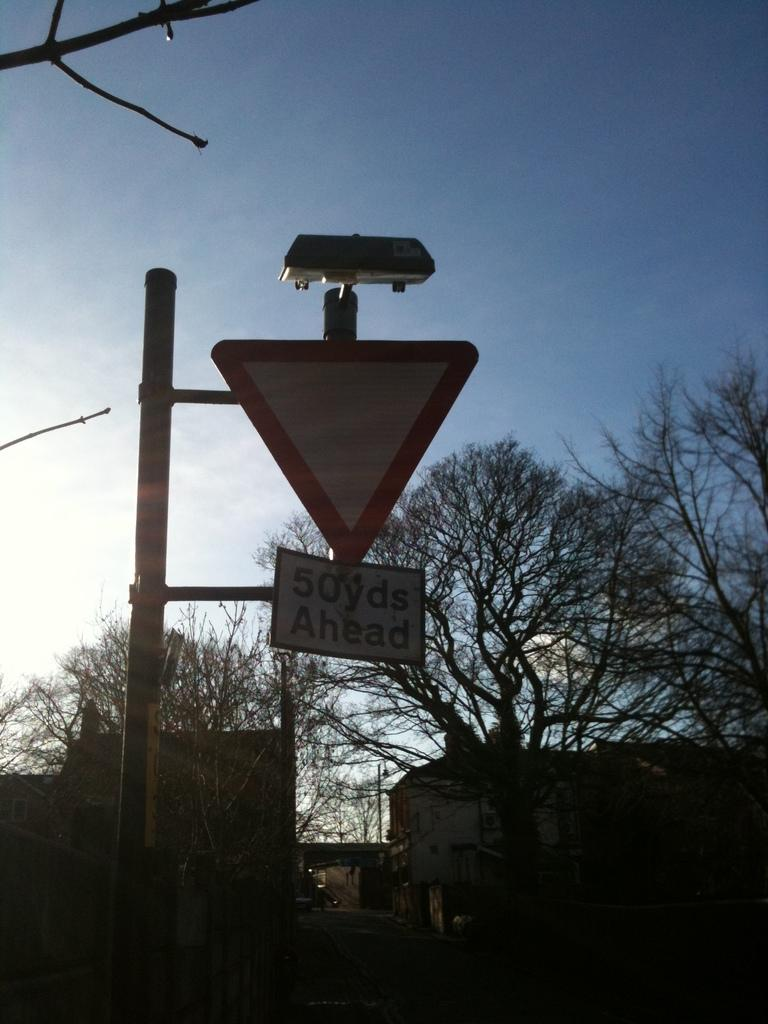What is the main structure in the image? There is a pole in the image. What else can be seen in the image besides the pole? There are boards, trees, buildings, and some objects in the image. Can you describe the natural elements in the image? There are trees in the image. What is visible in the background of the image? The sky is visible in the background of the image. What type of toothpaste is being used to clean the bike in the image? There is no bike or toothpaste present in the image. Is the bath visible in the image? There is no bath present in the image. 